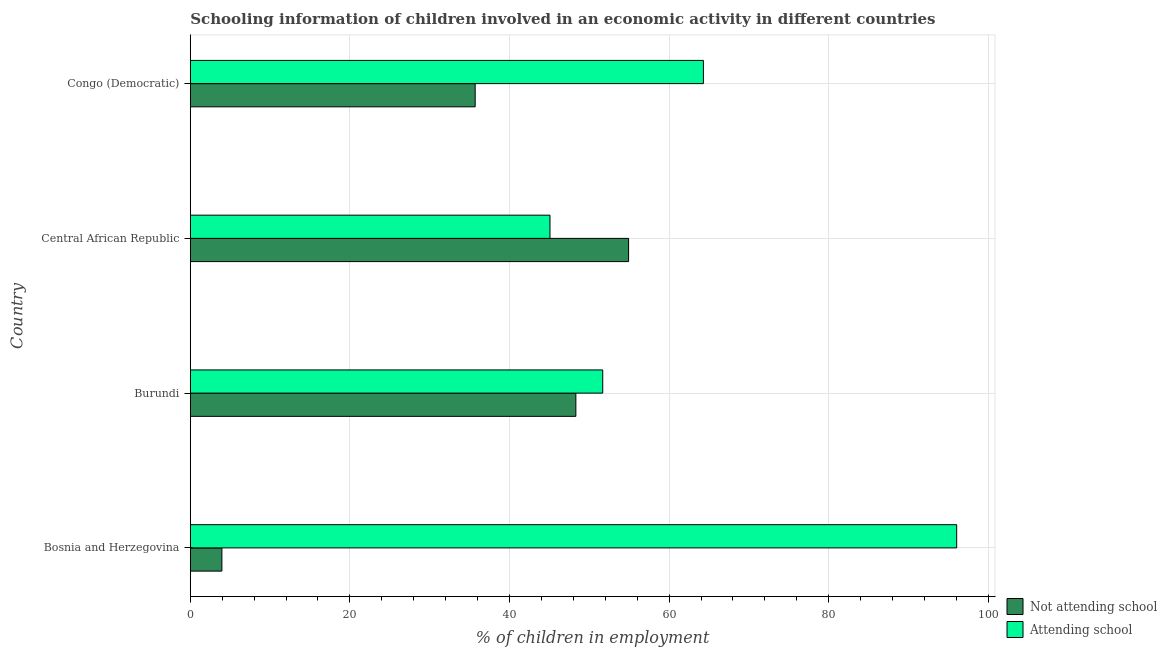Are the number of bars per tick equal to the number of legend labels?
Offer a very short reply. Yes. Are the number of bars on each tick of the Y-axis equal?
Provide a short and direct response. Yes. How many bars are there on the 3rd tick from the top?
Offer a terse response. 2. What is the label of the 1st group of bars from the top?
Offer a terse response. Congo (Democratic). In how many cases, is the number of bars for a given country not equal to the number of legend labels?
Your answer should be very brief. 0. What is the percentage of employed children who are attending school in Bosnia and Herzegovina?
Give a very brief answer. 96.04. Across all countries, what is the maximum percentage of employed children who are not attending school?
Offer a terse response. 54.93. Across all countries, what is the minimum percentage of employed children who are not attending school?
Make the answer very short. 3.96. In which country was the percentage of employed children who are attending school maximum?
Offer a very short reply. Bosnia and Herzegovina. In which country was the percentage of employed children who are not attending school minimum?
Offer a very short reply. Bosnia and Herzegovina. What is the total percentage of employed children who are not attending school in the graph?
Your response must be concise. 142.9. What is the difference between the percentage of employed children who are attending school in Burundi and that in Congo (Democratic)?
Your answer should be very brief. -12.62. What is the difference between the percentage of employed children who are attending school in Central African Republic and the percentage of employed children who are not attending school in Bosnia and Herzegovina?
Offer a terse response. 41.11. What is the average percentage of employed children who are attending school per country?
Your answer should be very brief. 64.28. What is the difference between the percentage of employed children who are not attending school and percentage of employed children who are attending school in Burundi?
Keep it short and to the point. -3.37. What is the ratio of the percentage of employed children who are not attending school in Burundi to that in Central African Republic?
Provide a short and direct response. 0.88. Is the percentage of employed children who are attending school in Bosnia and Herzegovina less than that in Central African Republic?
Provide a succinct answer. No. What is the difference between the highest and the second highest percentage of employed children who are attending school?
Offer a terse response. 31.74. What is the difference between the highest and the lowest percentage of employed children who are not attending school?
Give a very brief answer. 50.96. In how many countries, is the percentage of employed children who are attending school greater than the average percentage of employed children who are attending school taken over all countries?
Provide a short and direct response. 2. Is the sum of the percentage of employed children who are not attending school in Burundi and Congo (Democratic) greater than the maximum percentage of employed children who are attending school across all countries?
Ensure brevity in your answer.  No. What does the 1st bar from the top in Congo (Democratic) represents?
Give a very brief answer. Attending school. What does the 2nd bar from the bottom in Bosnia and Herzegovina represents?
Give a very brief answer. Attending school. How many bars are there?
Your response must be concise. 8. What is the difference between two consecutive major ticks on the X-axis?
Keep it short and to the point. 20. Are the values on the major ticks of X-axis written in scientific E-notation?
Ensure brevity in your answer.  No. Does the graph contain grids?
Offer a very short reply. Yes. How are the legend labels stacked?
Offer a very short reply. Vertical. What is the title of the graph?
Your answer should be compact. Schooling information of children involved in an economic activity in different countries. Does "Age 65(male)" appear as one of the legend labels in the graph?
Provide a short and direct response. No. What is the label or title of the X-axis?
Offer a very short reply. % of children in employment. What is the label or title of the Y-axis?
Provide a succinct answer. Country. What is the % of children in employment in Not attending school in Bosnia and Herzegovina?
Offer a very short reply. 3.96. What is the % of children in employment of Attending school in Bosnia and Herzegovina?
Make the answer very short. 96.04. What is the % of children in employment in Not attending school in Burundi?
Offer a very short reply. 48.32. What is the % of children in employment of Attending school in Burundi?
Make the answer very short. 51.68. What is the % of children in employment in Not attending school in Central African Republic?
Ensure brevity in your answer.  54.93. What is the % of children in employment of Attending school in Central African Republic?
Provide a short and direct response. 45.07. What is the % of children in employment in Not attending school in Congo (Democratic)?
Make the answer very short. 35.7. What is the % of children in employment of Attending school in Congo (Democratic)?
Offer a very short reply. 64.3. Across all countries, what is the maximum % of children in employment in Not attending school?
Your answer should be compact. 54.93. Across all countries, what is the maximum % of children in employment in Attending school?
Keep it short and to the point. 96.04. Across all countries, what is the minimum % of children in employment in Not attending school?
Keep it short and to the point. 3.96. Across all countries, what is the minimum % of children in employment of Attending school?
Provide a short and direct response. 45.07. What is the total % of children in employment in Not attending school in the graph?
Your answer should be compact. 142.9. What is the total % of children in employment in Attending school in the graph?
Keep it short and to the point. 257.1. What is the difference between the % of children in employment of Not attending school in Bosnia and Herzegovina and that in Burundi?
Keep it short and to the point. -44.36. What is the difference between the % of children in employment in Attending school in Bosnia and Herzegovina and that in Burundi?
Provide a short and direct response. 44.36. What is the difference between the % of children in employment in Not attending school in Bosnia and Herzegovina and that in Central African Republic?
Offer a very short reply. -50.97. What is the difference between the % of children in employment in Attending school in Bosnia and Herzegovina and that in Central African Republic?
Give a very brief answer. 50.97. What is the difference between the % of children in employment of Not attending school in Bosnia and Herzegovina and that in Congo (Democratic)?
Offer a very short reply. -31.74. What is the difference between the % of children in employment in Attending school in Bosnia and Herzegovina and that in Congo (Democratic)?
Provide a short and direct response. 31.74. What is the difference between the % of children in employment of Not attending school in Burundi and that in Central African Republic?
Keep it short and to the point. -6.61. What is the difference between the % of children in employment of Attending school in Burundi and that in Central African Republic?
Ensure brevity in your answer.  6.61. What is the difference between the % of children in employment in Not attending school in Burundi and that in Congo (Democratic)?
Provide a succinct answer. 12.62. What is the difference between the % of children in employment of Attending school in Burundi and that in Congo (Democratic)?
Your answer should be very brief. -12.62. What is the difference between the % of children in employment in Not attending school in Central African Republic and that in Congo (Democratic)?
Ensure brevity in your answer.  19.23. What is the difference between the % of children in employment of Attending school in Central African Republic and that in Congo (Democratic)?
Your response must be concise. -19.23. What is the difference between the % of children in employment in Not attending school in Bosnia and Herzegovina and the % of children in employment in Attending school in Burundi?
Provide a short and direct response. -47.72. What is the difference between the % of children in employment in Not attending school in Bosnia and Herzegovina and the % of children in employment in Attending school in Central African Republic?
Your response must be concise. -41.11. What is the difference between the % of children in employment in Not attending school in Bosnia and Herzegovina and the % of children in employment in Attending school in Congo (Democratic)?
Give a very brief answer. -60.34. What is the difference between the % of children in employment in Not attending school in Burundi and the % of children in employment in Attending school in Central African Republic?
Offer a very short reply. 3.24. What is the difference between the % of children in employment in Not attending school in Burundi and the % of children in employment in Attending school in Congo (Democratic)?
Make the answer very short. -15.98. What is the difference between the % of children in employment in Not attending school in Central African Republic and the % of children in employment in Attending school in Congo (Democratic)?
Provide a short and direct response. -9.37. What is the average % of children in employment of Not attending school per country?
Provide a succinct answer. 35.73. What is the average % of children in employment in Attending school per country?
Offer a very short reply. 64.27. What is the difference between the % of children in employment of Not attending school and % of children in employment of Attending school in Bosnia and Herzegovina?
Provide a succinct answer. -92.08. What is the difference between the % of children in employment of Not attending school and % of children in employment of Attending school in Burundi?
Provide a short and direct response. -3.37. What is the difference between the % of children in employment of Not attending school and % of children in employment of Attending school in Central African Republic?
Your answer should be compact. 9.85. What is the difference between the % of children in employment of Not attending school and % of children in employment of Attending school in Congo (Democratic)?
Offer a very short reply. -28.6. What is the ratio of the % of children in employment in Not attending school in Bosnia and Herzegovina to that in Burundi?
Offer a terse response. 0.08. What is the ratio of the % of children in employment of Attending school in Bosnia and Herzegovina to that in Burundi?
Ensure brevity in your answer.  1.86. What is the ratio of the % of children in employment of Not attending school in Bosnia and Herzegovina to that in Central African Republic?
Give a very brief answer. 0.07. What is the ratio of the % of children in employment of Attending school in Bosnia and Herzegovina to that in Central African Republic?
Provide a succinct answer. 2.13. What is the ratio of the % of children in employment of Not attending school in Bosnia and Herzegovina to that in Congo (Democratic)?
Offer a very short reply. 0.11. What is the ratio of the % of children in employment of Attending school in Bosnia and Herzegovina to that in Congo (Democratic)?
Keep it short and to the point. 1.49. What is the ratio of the % of children in employment of Not attending school in Burundi to that in Central African Republic?
Your answer should be very brief. 0.88. What is the ratio of the % of children in employment of Attending school in Burundi to that in Central African Republic?
Provide a short and direct response. 1.15. What is the ratio of the % of children in employment in Not attending school in Burundi to that in Congo (Democratic)?
Your answer should be very brief. 1.35. What is the ratio of the % of children in employment in Attending school in Burundi to that in Congo (Democratic)?
Offer a very short reply. 0.8. What is the ratio of the % of children in employment in Not attending school in Central African Republic to that in Congo (Democratic)?
Offer a terse response. 1.54. What is the ratio of the % of children in employment in Attending school in Central African Republic to that in Congo (Democratic)?
Your response must be concise. 0.7. What is the difference between the highest and the second highest % of children in employment of Not attending school?
Provide a succinct answer. 6.61. What is the difference between the highest and the second highest % of children in employment of Attending school?
Provide a short and direct response. 31.74. What is the difference between the highest and the lowest % of children in employment of Not attending school?
Ensure brevity in your answer.  50.97. What is the difference between the highest and the lowest % of children in employment of Attending school?
Offer a terse response. 50.97. 